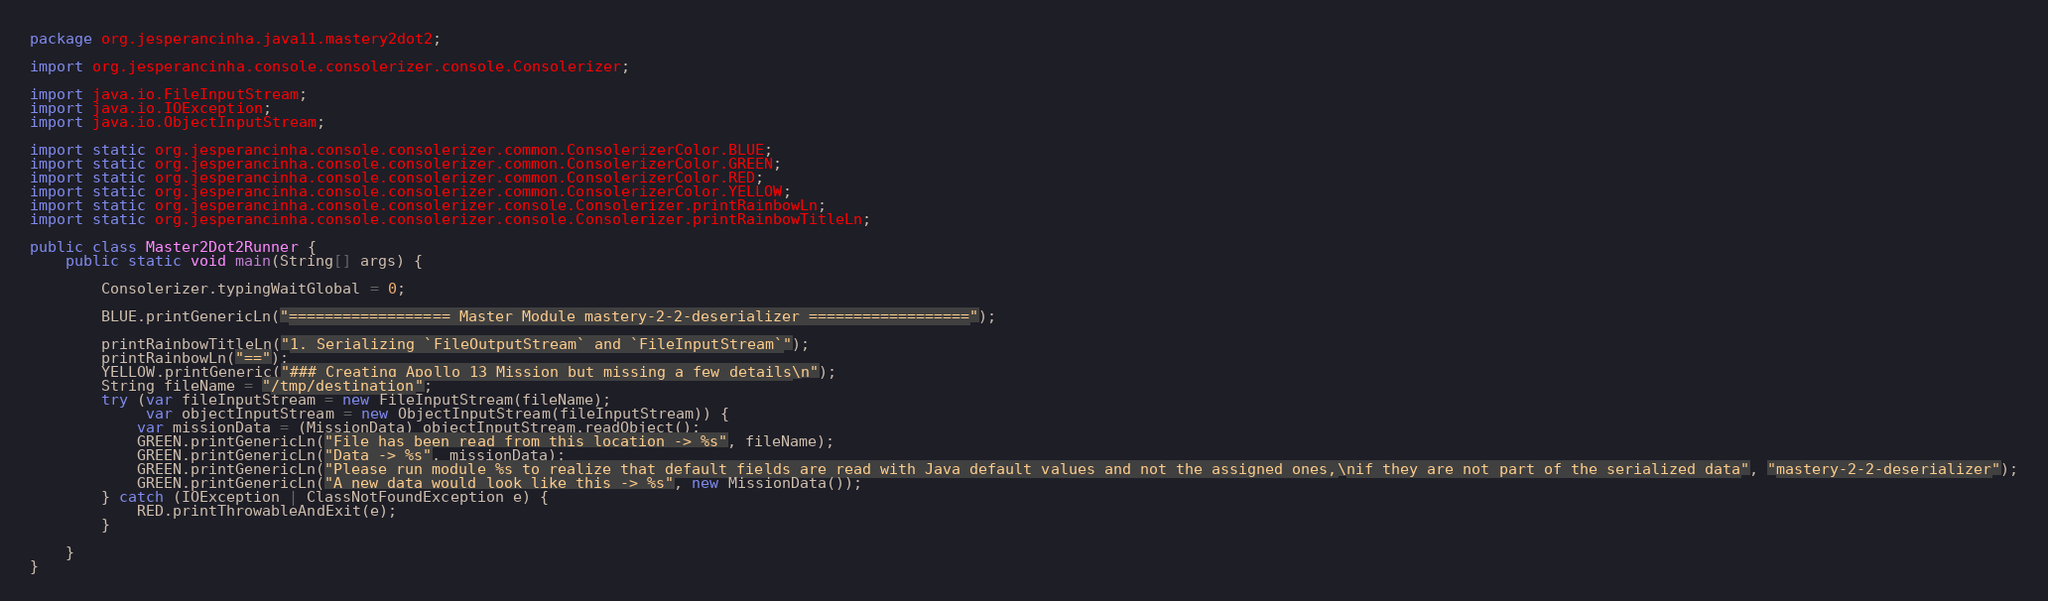<code> <loc_0><loc_0><loc_500><loc_500><_Java_>package org.jesperancinha.java11.mastery2dot2;

import org.jesperancinha.console.consolerizer.console.Consolerizer;

import java.io.FileInputStream;
import java.io.IOException;
import java.io.ObjectInputStream;

import static org.jesperancinha.console.consolerizer.common.ConsolerizerColor.BLUE;
import static org.jesperancinha.console.consolerizer.common.ConsolerizerColor.GREEN;
import static org.jesperancinha.console.consolerizer.common.ConsolerizerColor.RED;
import static org.jesperancinha.console.consolerizer.common.ConsolerizerColor.YELLOW;
import static org.jesperancinha.console.consolerizer.console.Consolerizer.printRainbowLn;
import static org.jesperancinha.console.consolerizer.console.Consolerizer.printRainbowTitleLn;

public class Master2Dot2Runner {
    public static void main(String[] args) {

        Consolerizer.typingWaitGlobal = 0;

        BLUE.printGenericLn("================== Master Module mastery-2-2-deserializer ==================");

        printRainbowTitleLn("1. Serializing `FileOutputStream` and `FileInputStream`");
        printRainbowLn("==");
        YELLOW.printGeneric("### Creating Apollo 13 Mission but missing a few details\n");
        String fileName = "/tmp/destination";
        try (var fileInputStream = new FileInputStream(fileName);
             var objectInputStream = new ObjectInputStream(fileInputStream)) {
            var missionData = (MissionData) objectInputStream.readObject();
            GREEN.printGenericLn("File has been read from this location -> %s", fileName);
            GREEN.printGenericLn("Data -> %s", missionData);
            GREEN.printGenericLn("Please run module %s to realize that default fields are read with Java default values and not the assigned ones,\nif they are not part of the serialized data", "mastery-2-2-deserializer");
            GREEN.printGenericLn("A new data would look like this -> %s", new MissionData());
        } catch (IOException | ClassNotFoundException e) {
            RED.printThrowableAndExit(e);
        }

    }
}
</code> 